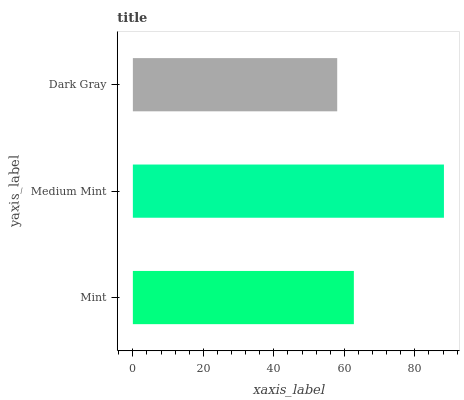Is Dark Gray the minimum?
Answer yes or no. Yes. Is Medium Mint the maximum?
Answer yes or no. Yes. Is Medium Mint the minimum?
Answer yes or no. No. Is Dark Gray the maximum?
Answer yes or no. No. Is Medium Mint greater than Dark Gray?
Answer yes or no. Yes. Is Dark Gray less than Medium Mint?
Answer yes or no. Yes. Is Dark Gray greater than Medium Mint?
Answer yes or no. No. Is Medium Mint less than Dark Gray?
Answer yes or no. No. Is Mint the high median?
Answer yes or no. Yes. Is Mint the low median?
Answer yes or no. Yes. Is Dark Gray the high median?
Answer yes or no. No. Is Medium Mint the low median?
Answer yes or no. No. 